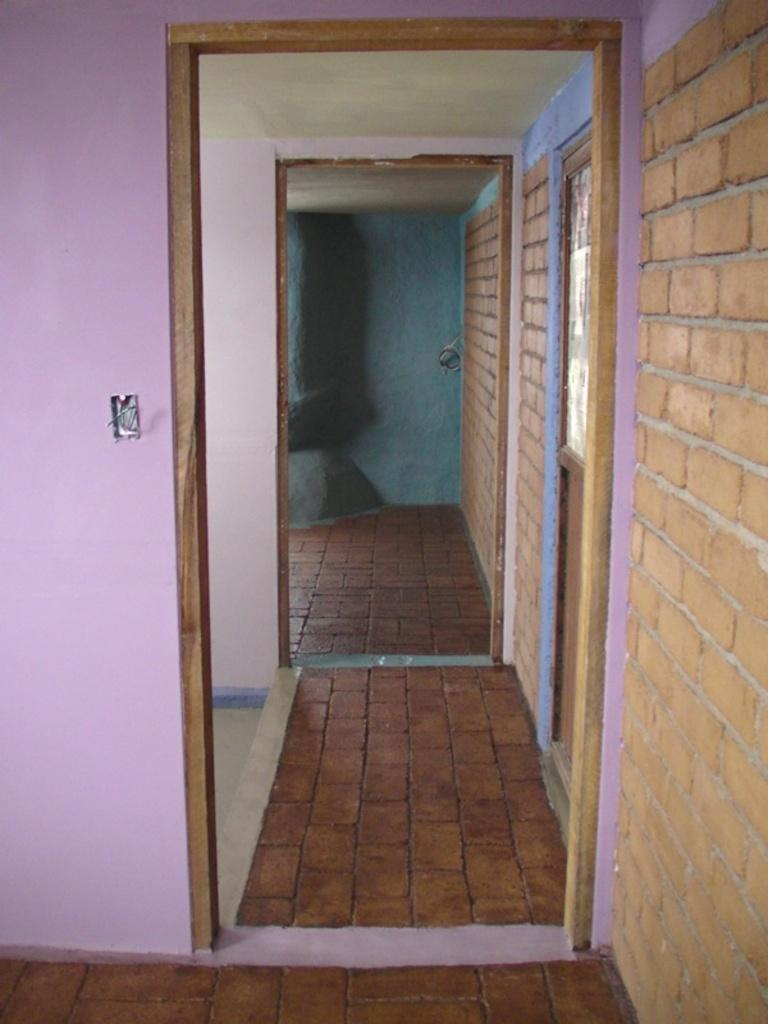What type of location is depicted in the image? The image shows the interior of a house. What colors are used on the walls in the image? The walls have pink and blue colors. Can you describe the wall on the right side of the image? There is a brown color brick wall on the right side of the image. How many trains can be seen in the image? There are no trains present in the image; it shows the interior of a house with walls of various colors. 